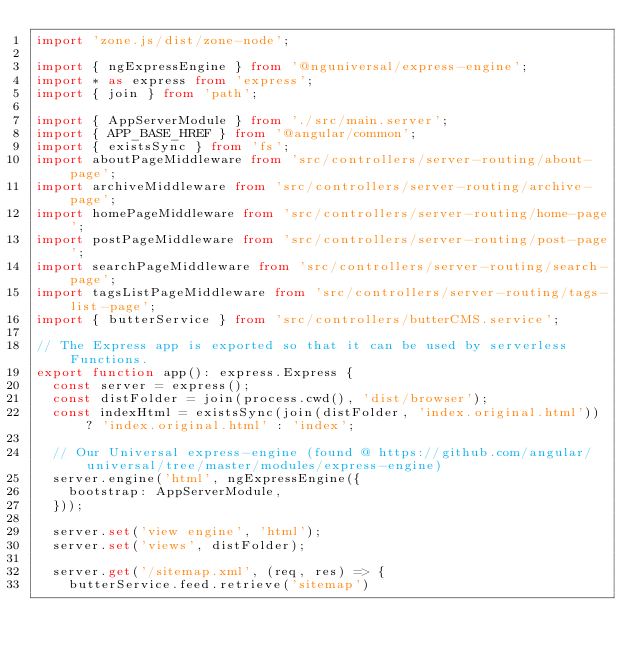Convert code to text. <code><loc_0><loc_0><loc_500><loc_500><_TypeScript_>import 'zone.js/dist/zone-node';

import { ngExpressEngine } from '@nguniversal/express-engine';
import * as express from 'express';
import { join } from 'path';

import { AppServerModule } from './src/main.server';
import { APP_BASE_HREF } from '@angular/common';
import { existsSync } from 'fs';
import aboutPageMiddleware from 'src/controllers/server-routing/about-page';
import archiveMiddleware from 'src/controllers/server-routing/archive-page';
import homePageMiddleware from 'src/controllers/server-routing/home-page';
import postPageMiddleware from 'src/controllers/server-routing/post-page';
import searchPageMiddleware from 'src/controllers/server-routing/search-page';
import tagsListPageMiddleware from 'src/controllers/server-routing/tags-list-page';
import { butterService } from 'src/controllers/butterCMS.service';

// The Express app is exported so that it can be used by serverless Functions.
export function app(): express.Express {
  const server = express();
  const distFolder = join(process.cwd(), 'dist/browser');
  const indexHtml = existsSync(join(distFolder, 'index.original.html')) ? 'index.original.html' : 'index';

  // Our Universal express-engine (found @ https://github.com/angular/universal/tree/master/modules/express-engine)
  server.engine('html', ngExpressEngine({
    bootstrap: AppServerModule,
  }));

  server.set('view engine', 'html');
  server.set('views', distFolder);

  server.get('/sitemap.xml', (req, res) => {
    butterService.feed.retrieve('sitemap')</code> 